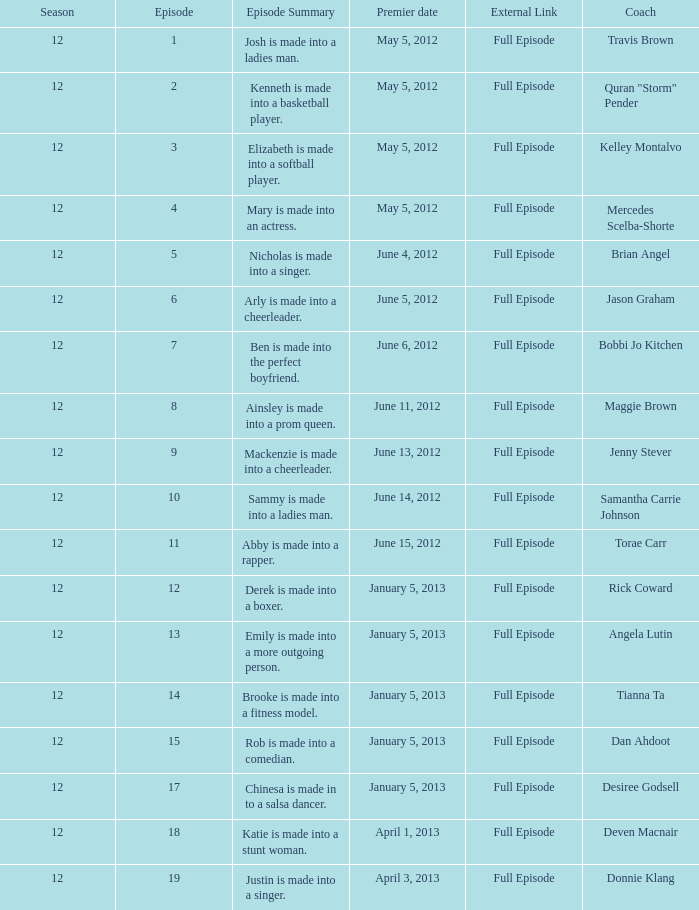Provide the episode description for travis brown. Josh is made into a ladies man. 